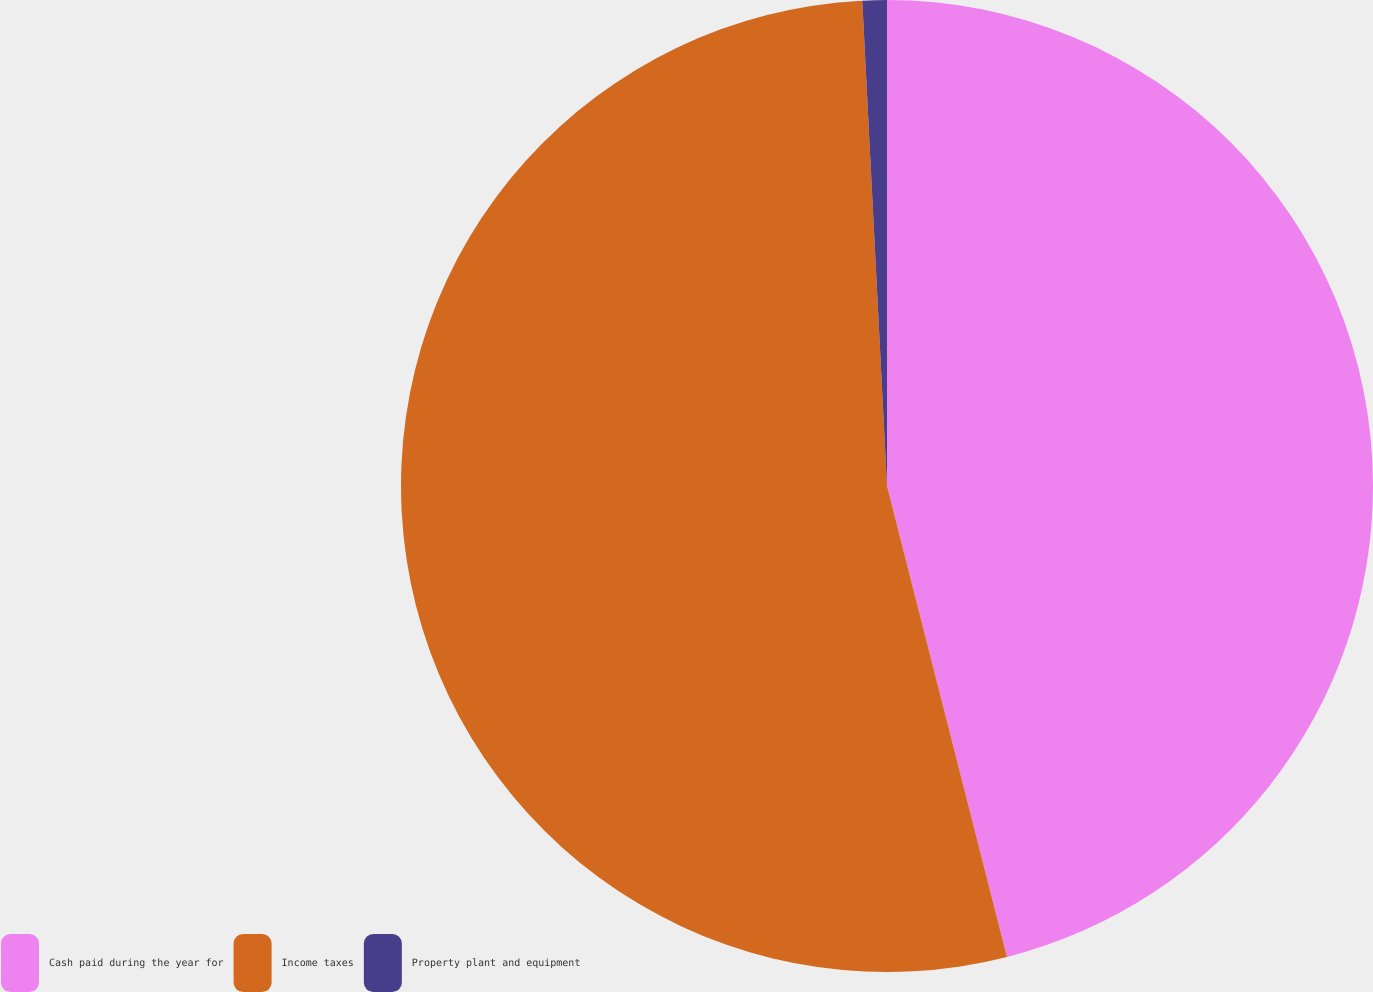Convert chart to OTSL. <chart><loc_0><loc_0><loc_500><loc_500><pie_chart><fcel>Cash paid during the year for<fcel>Income taxes<fcel>Property plant and equipment<nl><fcel>46.03%<fcel>53.16%<fcel>0.81%<nl></chart> 